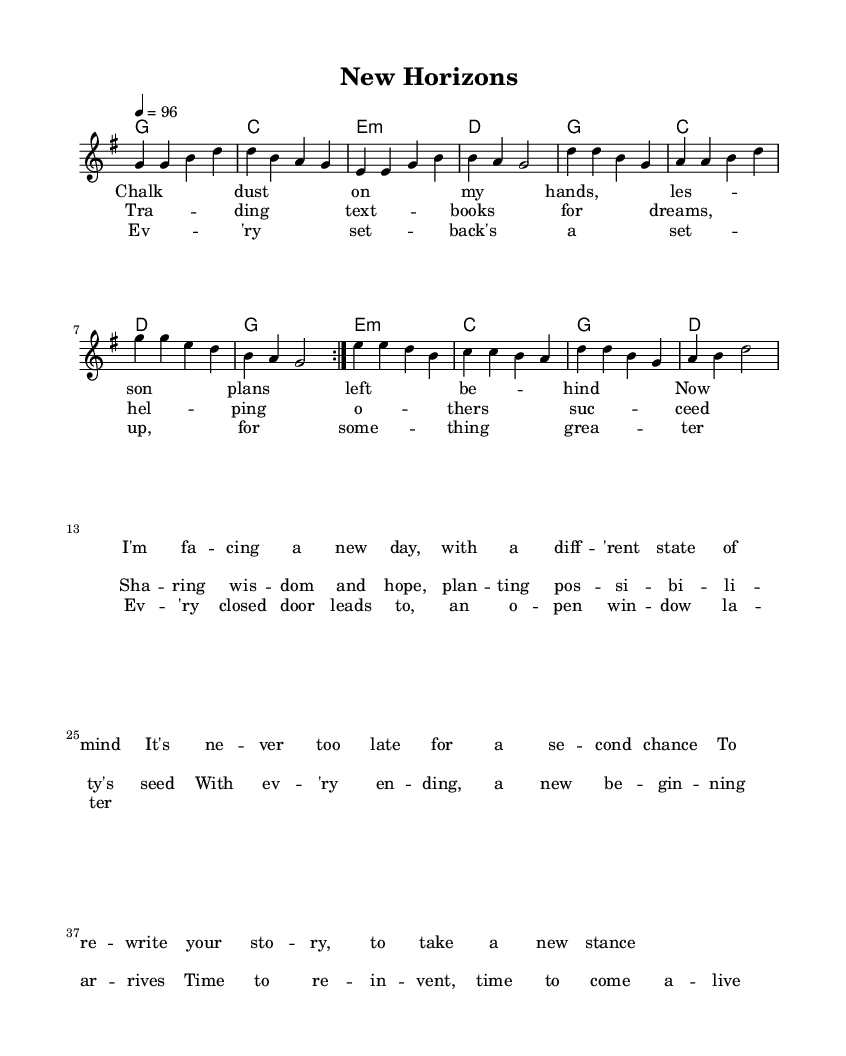What is the key signature of this music? The key signature is G major, which has one sharp (F#). This can be identified from the key indication at the beginning of the piece.
Answer: G major What is the time signature of this music? The time signature is 4/4, indicated at the beginning of the score. This means there are four beats in each measure, and the quarter note gets one beat.
Answer: 4/4 What is the tempo marking for this composition? The tempo marking is 96 beats per minute, indicated in the score with "4 = 96." This means the quarter note will be played at a speed of 96 beats per minute.
Answer: 96 How many verses are present in this piece? There are two verses in the song, as indicated by the lyrical sections labeled as "verseOne" and "verseTwo" in the score.
Answer: Two What thematic element is emphasized in the lyrics? The lyrics emphasize themes of reinvention and second chances, with lines referring to "a new day" and "time to re-invent." This focus on personal growth aligns with country rock values.
Answer: Reinvention What is the mood conveyed through the melody based on the key signature? The key of G major typically conveys a bright and uplifting mood, which is supported by the lyrics discussing new beginnings and hope. The combination creates a positive feeling throughout the piece.
Answer: Uplifting 